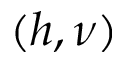Convert formula to latex. <formula><loc_0><loc_0><loc_500><loc_500>( h , \nu )</formula> 